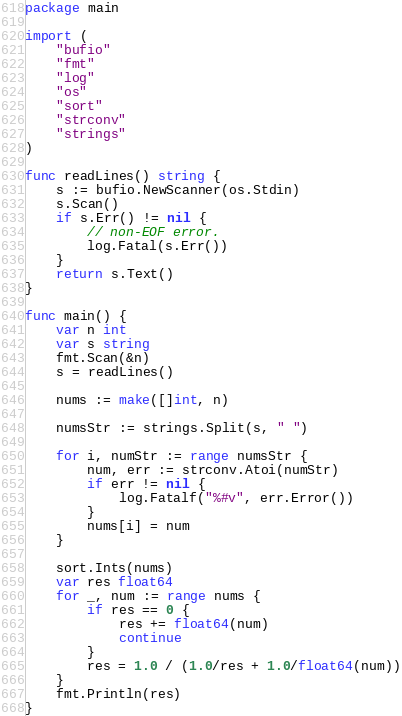<code> <loc_0><loc_0><loc_500><loc_500><_Go_>package main

import (
	"bufio"
	"fmt"
	"log"
	"os"
	"sort"
	"strconv"
	"strings"
)

func readLines() string {
	s := bufio.NewScanner(os.Stdin)
	s.Scan()
	if s.Err() != nil {
		// non-EOF error.
		log.Fatal(s.Err())
	}
	return s.Text()
}

func main() {
	var n int
	var s string
	fmt.Scan(&n)
	s = readLines()

	nums := make([]int, n)

	numsStr := strings.Split(s, " ")

	for i, numStr := range numsStr {
		num, err := strconv.Atoi(numStr)
		if err != nil {
			log.Fatalf("%#v", err.Error())
		}
		nums[i] = num
	}

	sort.Ints(nums)
	var res float64
	for _, num := range nums {
		if res == 0 {
			res += float64(num)
			continue
		}
		res = 1.0 / (1.0/res + 1.0/float64(num))
	}
	fmt.Println(res)
}
</code> 